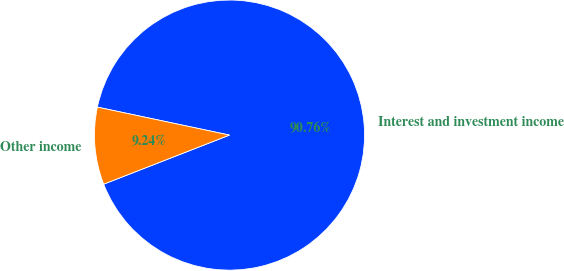Convert chart to OTSL. <chart><loc_0><loc_0><loc_500><loc_500><pie_chart><fcel>Interest and investment income<fcel>Other income<nl><fcel>90.76%<fcel>9.24%<nl></chart> 